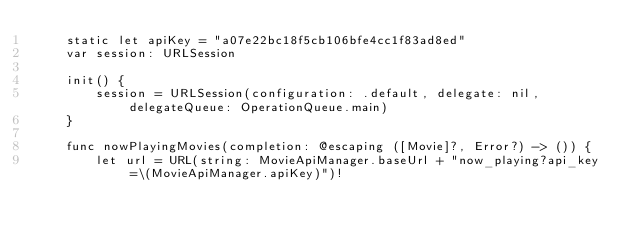<code> <loc_0><loc_0><loc_500><loc_500><_Swift_>    static let apiKey = "a07e22bc18f5cb106bfe4cc1f83ad8ed"
    var session: URLSession
    
    init() {
        session = URLSession(configuration: .default, delegate: nil, delegateQueue: OperationQueue.main)
    }
    
    func nowPlayingMovies(completion: @escaping ([Movie]?, Error?) -> ()) {
        let url = URL(string: MovieApiManager.baseUrl + "now_playing?api_key=\(MovieApiManager.apiKey)")!</code> 